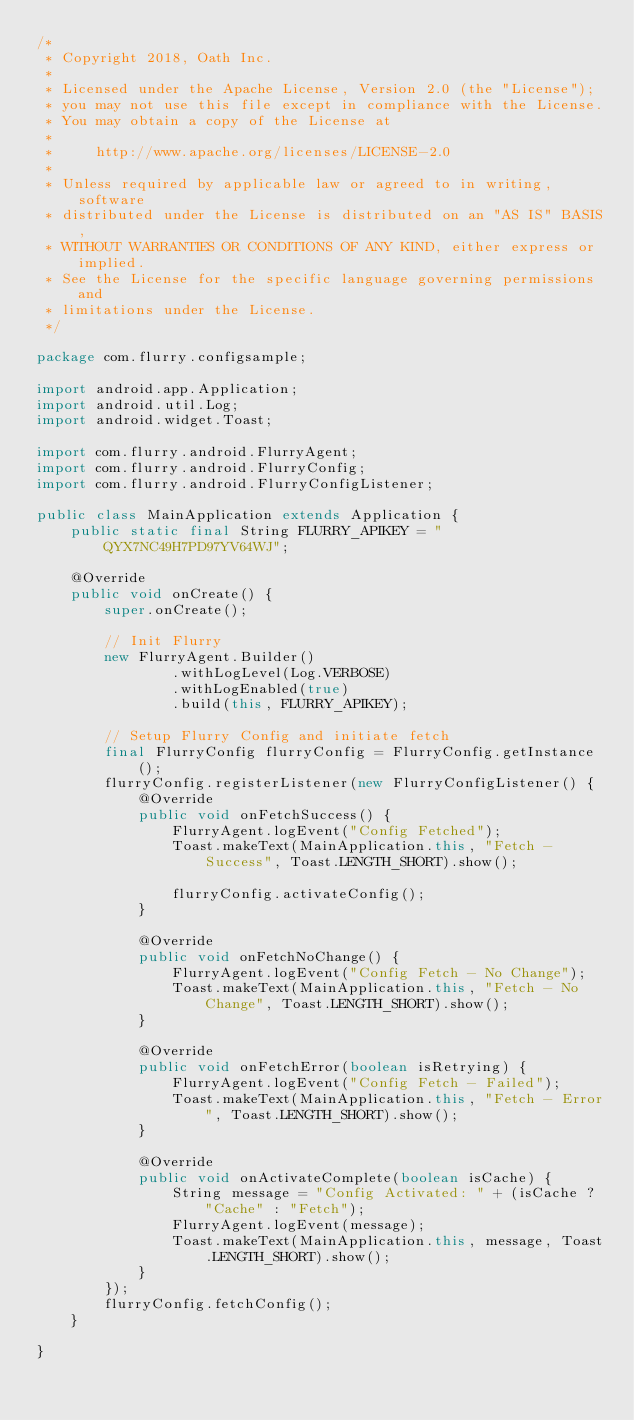<code> <loc_0><loc_0><loc_500><loc_500><_Java_>/*
 * Copyright 2018, Oath Inc.
 *
 * Licensed under the Apache License, Version 2.0 (the "License");
 * you may not use this file except in compliance with the License.
 * You may obtain a copy of the License at
 *
 *     http://www.apache.org/licenses/LICENSE-2.0
 *
 * Unless required by applicable law or agreed to in writing, software
 * distributed under the License is distributed on an "AS IS" BASIS,
 * WITHOUT WARRANTIES OR CONDITIONS OF ANY KIND, either express or implied.
 * See the License for the specific language governing permissions and
 * limitations under the License.
 */

package com.flurry.configsample;

import android.app.Application;
import android.util.Log;
import android.widget.Toast;

import com.flurry.android.FlurryAgent;
import com.flurry.android.FlurryConfig;
import com.flurry.android.FlurryConfigListener;

public class MainApplication extends Application {
    public static final String FLURRY_APIKEY = "QYX7NC49H7PD97YV64WJ";

    @Override
    public void onCreate() {
        super.onCreate();

        // Init Flurry
        new FlurryAgent.Builder()
                .withLogLevel(Log.VERBOSE)
                .withLogEnabled(true)
                .build(this, FLURRY_APIKEY);

        // Setup Flurry Config and initiate fetch
        final FlurryConfig flurryConfig = FlurryConfig.getInstance();
        flurryConfig.registerListener(new FlurryConfigListener() {
            @Override
            public void onFetchSuccess() {
                FlurryAgent.logEvent("Config Fetched");
                Toast.makeText(MainApplication.this, "Fetch - Success", Toast.LENGTH_SHORT).show();

                flurryConfig.activateConfig();
            }

            @Override
            public void onFetchNoChange() {
                FlurryAgent.logEvent("Config Fetch - No Change");
                Toast.makeText(MainApplication.this, "Fetch - No Change", Toast.LENGTH_SHORT).show();
            }

            @Override
            public void onFetchError(boolean isRetrying) {
                FlurryAgent.logEvent("Config Fetch - Failed");
                Toast.makeText(MainApplication.this, "Fetch - Error", Toast.LENGTH_SHORT).show();
            }

            @Override
            public void onActivateComplete(boolean isCache) {
                String message = "Config Activated: " + (isCache ? "Cache" : "Fetch");
                FlurryAgent.logEvent(message);
                Toast.makeText(MainApplication.this, message, Toast.LENGTH_SHORT).show();
            }
        });
        flurryConfig.fetchConfig();
    }

}
</code> 